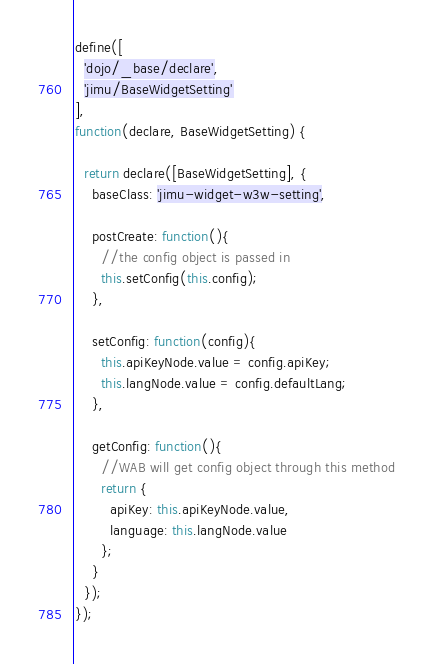<code> <loc_0><loc_0><loc_500><loc_500><_JavaScript_>define([
  'dojo/_base/declare',
  'jimu/BaseWidgetSetting'
],
function(declare, BaseWidgetSetting) {

  return declare([BaseWidgetSetting], {
    baseClass: 'jimu-widget-w3w-setting',

    postCreate: function(){
      //the config object is passed in
      this.setConfig(this.config);
    },

    setConfig: function(config){
      this.apiKeyNode.value = config.apiKey;
      this.langNode.value = config.defaultLang;
    },

    getConfig: function(){
      //WAB will get config object through this method
      return {
        apiKey: this.apiKeyNode.value,
        language: this.langNode.value
      };
    }
  });
});
</code> 